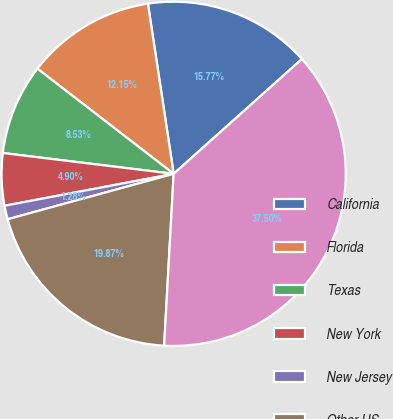<chart> <loc_0><loc_0><loc_500><loc_500><pie_chart><fcel>California<fcel>Florida<fcel>Texas<fcel>New York<fcel>New Jersey<fcel>Other US<fcel>Total credit card - domestic<nl><fcel>15.77%<fcel>12.15%<fcel>8.53%<fcel>4.9%<fcel>1.28%<fcel>19.87%<fcel>37.5%<nl></chart> 